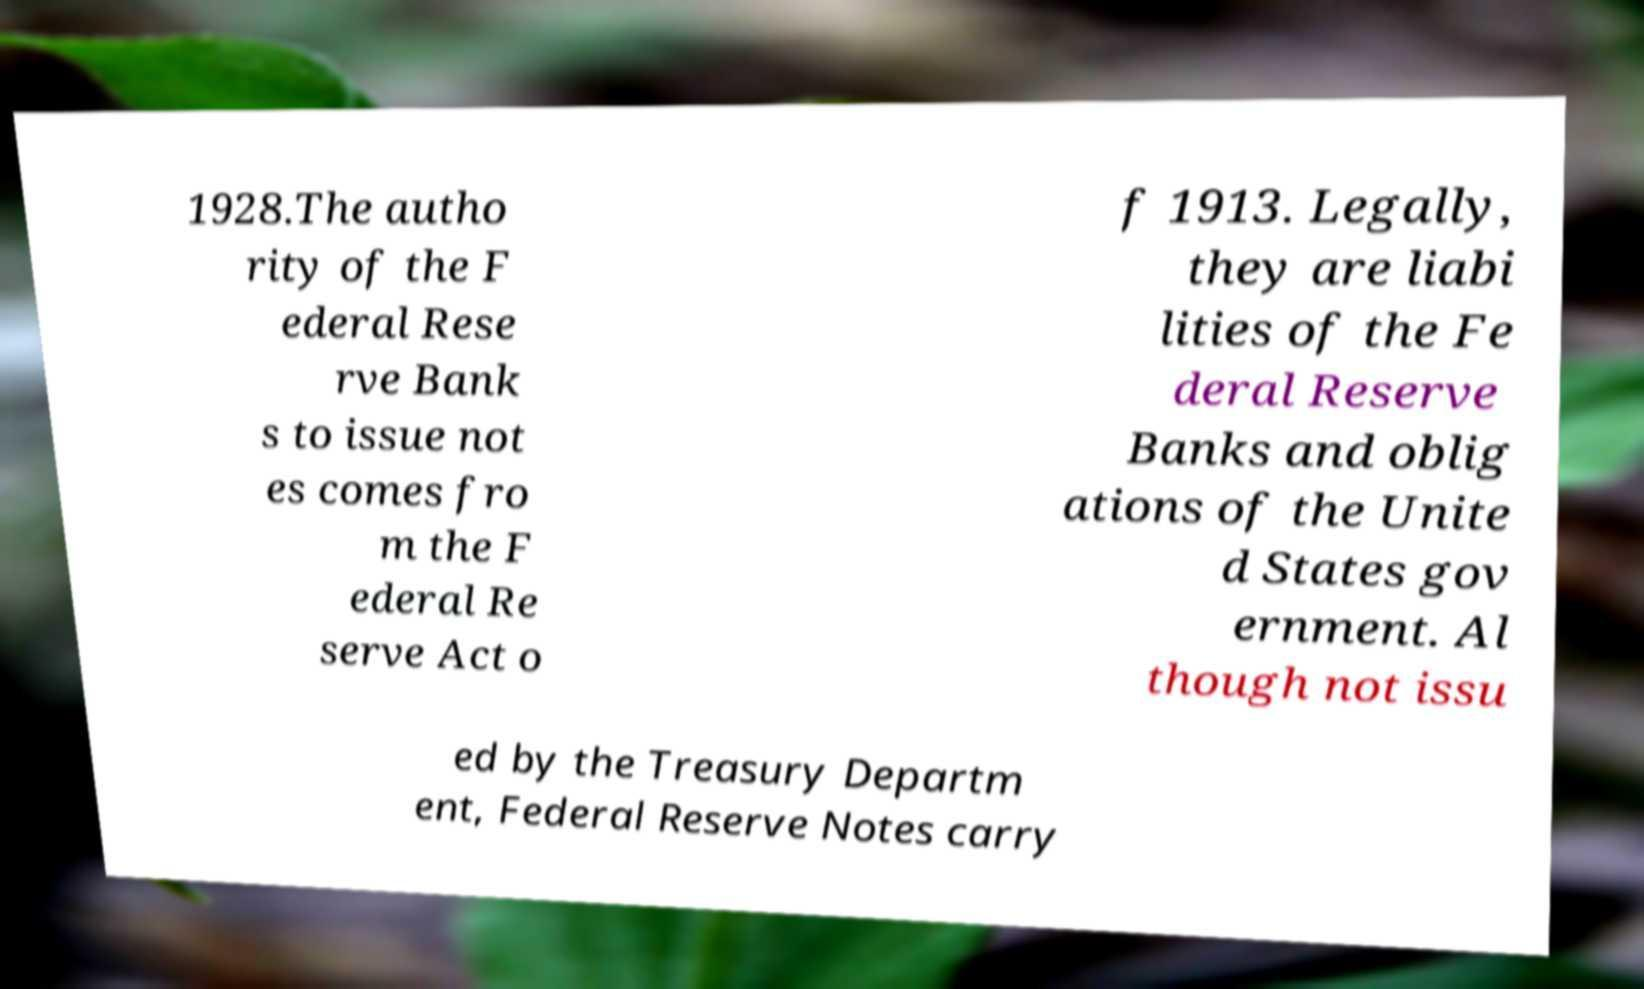For documentation purposes, I need the text within this image transcribed. Could you provide that? 1928.The autho rity of the F ederal Rese rve Bank s to issue not es comes fro m the F ederal Re serve Act o f 1913. Legally, they are liabi lities of the Fe deral Reserve Banks and oblig ations of the Unite d States gov ernment. Al though not issu ed by the Treasury Departm ent, Federal Reserve Notes carry 